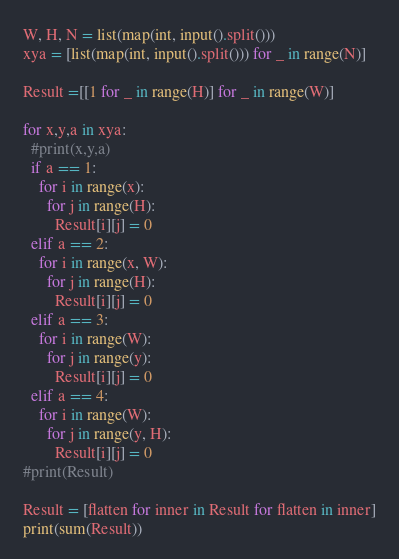<code> <loc_0><loc_0><loc_500><loc_500><_Python_>W, H, N = list(map(int, input().split()))
xya = [list(map(int, input().split())) for _ in range(N)]

Result =[[1 for _ in range(H)] for _ in range(W)]

for x,y,a in xya:
  #print(x,y,a)
  if a == 1:
    for i in range(x):
      for j in range(H):
        Result[i][j] = 0
  elif a == 2:
    for i in range(x, W):
      for j in range(H):
        Result[i][j] = 0
  elif a == 3:
    for i in range(W):
      for j in range(y):
        Result[i][j] = 0
  elif a == 4:
    for i in range(W):
      for j in range(y, H):
        Result[i][j] = 0
#print(Result)

Result = [flatten for inner in Result for flatten in inner]
print(sum(Result))</code> 